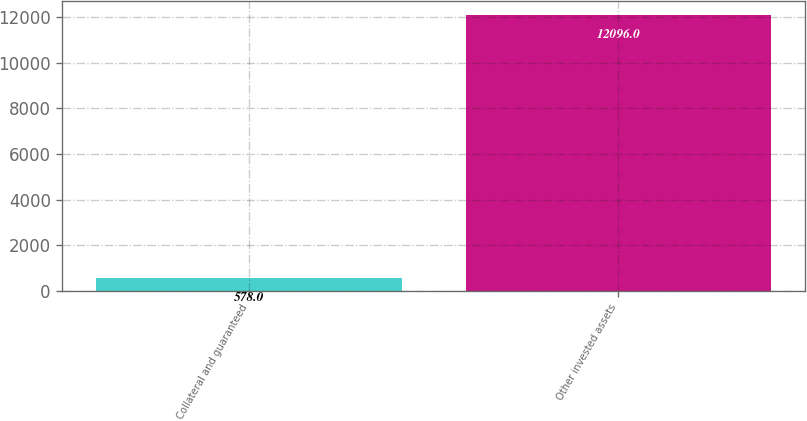Convert chart. <chart><loc_0><loc_0><loc_500><loc_500><bar_chart><fcel>Collateral and guaranteed<fcel>Other invested assets<nl><fcel>578<fcel>12096<nl></chart> 